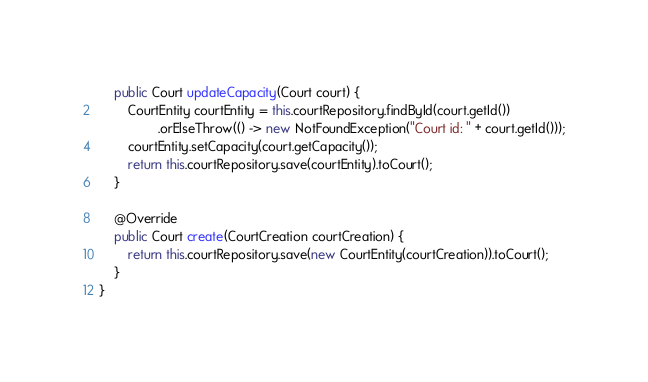Convert code to text. <code><loc_0><loc_0><loc_500><loc_500><_Java_>    public Court updateCapacity(Court court) {
        CourtEntity courtEntity = this.courtRepository.findById(court.getId())
                .orElseThrow(() -> new NotFoundException("Court id: " + court.getId()));
        courtEntity.setCapacity(court.getCapacity());
        return this.courtRepository.save(courtEntity).toCourt();
    }

    @Override
    public Court create(CourtCreation courtCreation) {
        return this.courtRepository.save(new CourtEntity(courtCreation)).toCourt();
    }
}
</code> 